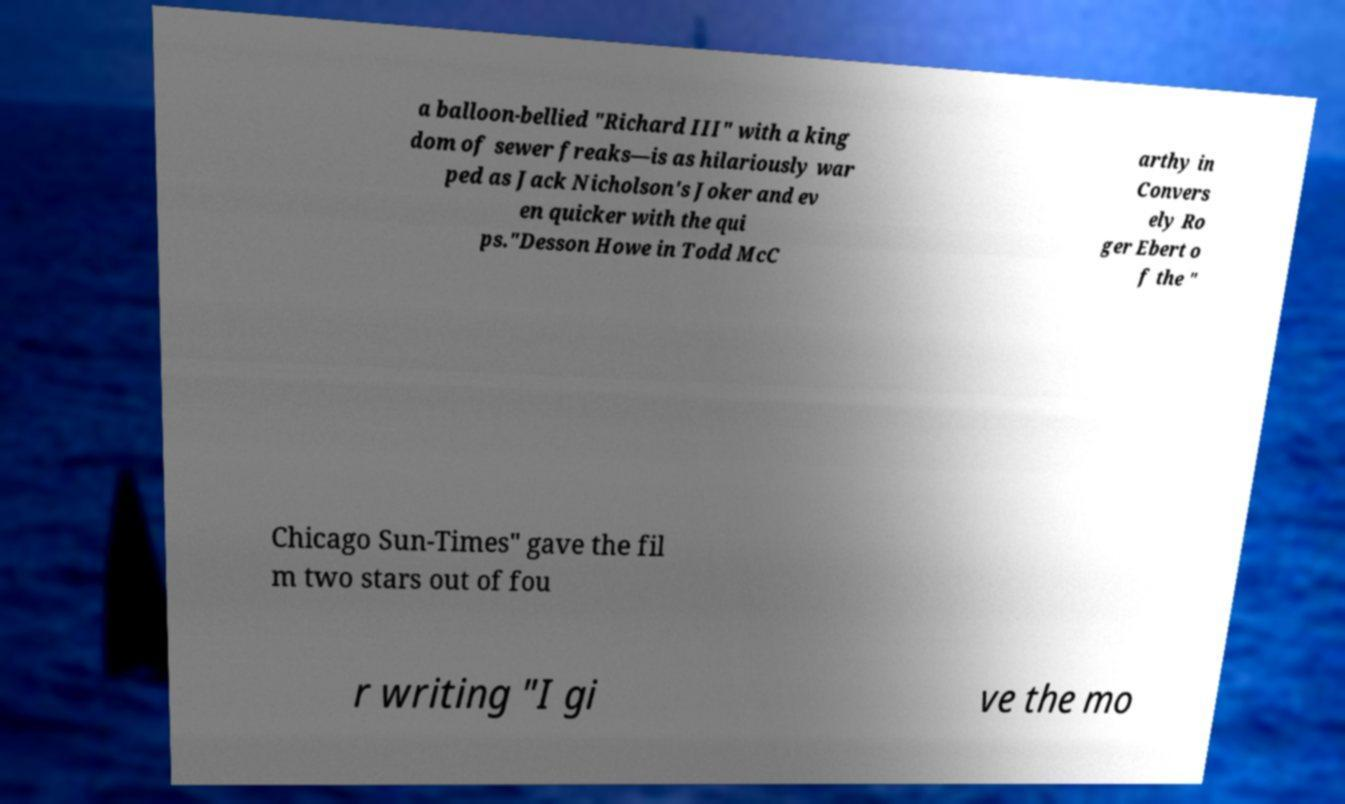Please identify and transcribe the text found in this image. a balloon-bellied "Richard III" with a king dom of sewer freaks—is as hilariously war ped as Jack Nicholson's Joker and ev en quicker with the qui ps."Desson Howe in Todd McC arthy in Convers ely Ro ger Ebert o f the " Chicago Sun-Times" gave the fil m two stars out of fou r writing "I gi ve the mo 